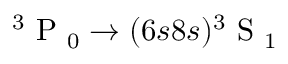Convert formula to latex. <formula><loc_0><loc_0><loc_500><loc_500>{ { ^ { 3 } P _ { 0 } } } \rightarrow ( 6 s 8 s ) { { ^ { 3 } S _ { 1 } } }</formula> 